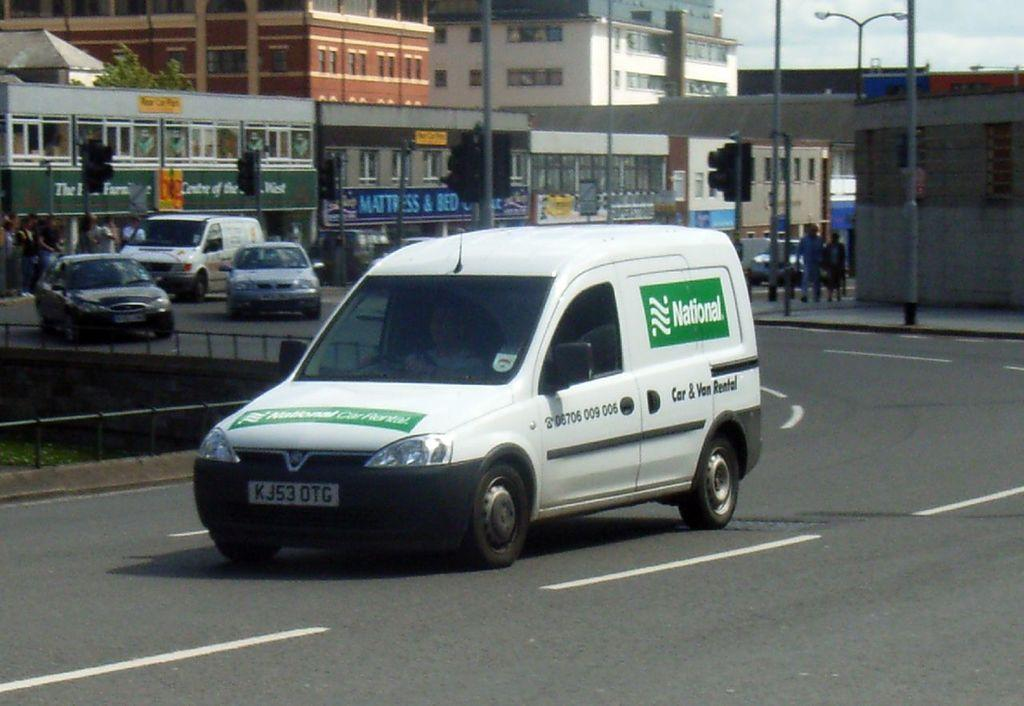What can be seen on the road in the image? There are vehicles on the road in the image. What is visible in the background of the image? The sky, buildings, street lights, poles, and people are visible in the background of the image. What type of barrier is present in the image? There is a fence in the image. What markings can be seen on the road? White lines are visible on the road. Where are the plants located in the image? There are no plants visible in the image. What type of writing instrument is being used by the person in the image? There is no person using a quill or any other writing instrument in the image. 